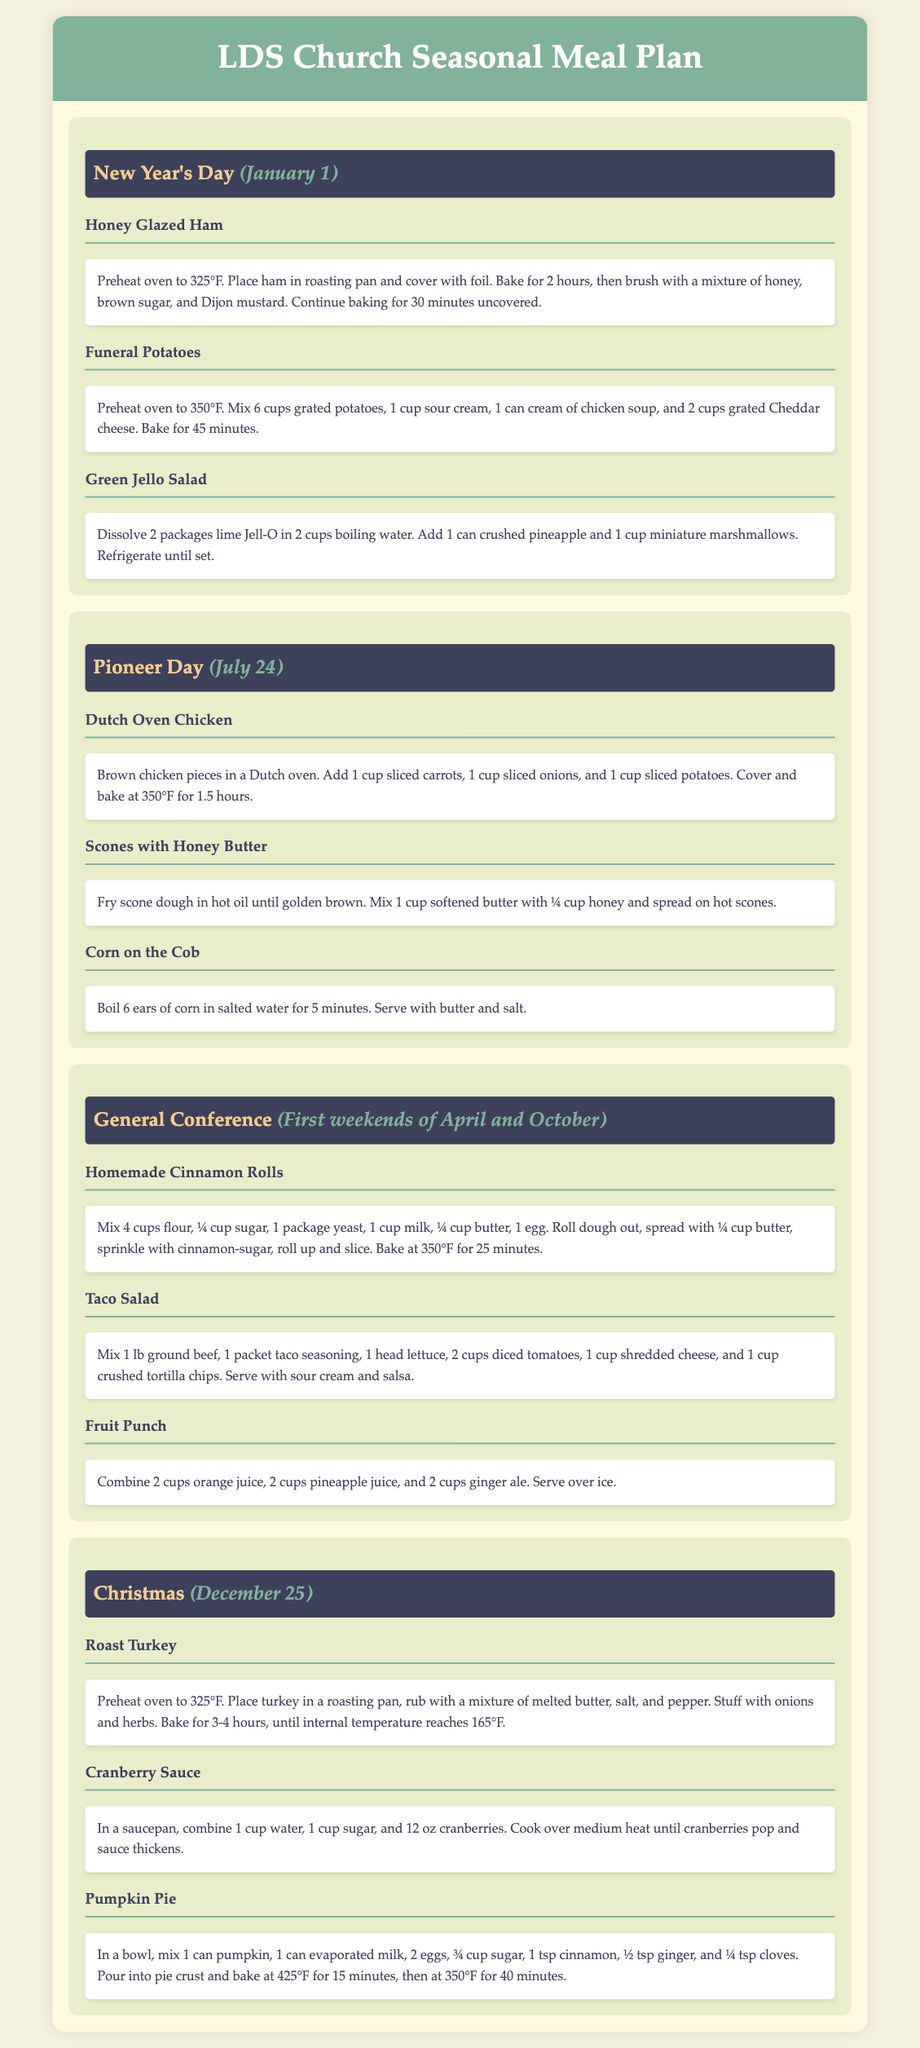What is the first dish listed for New Year's Day? The first dish is Honey Glazed Ham, as it is the first item in the New Year's meal plan section.
Answer: Honey Glazed Ham What date is Pioneer Day celebrated? The document states that Pioneer Day is on July 24, which is specified in the date section of the event.
Answer: July 24 How long do you bake the Honey Glazed Ham? The recipe states that the ham is baked for a total of 2 hours and then an additional 30 minutes uncovered.
Answer: 2 hours and 30 minutes What ingredient is used in the Funeral Potatoes recipe that provides creaminess? The recipe includes sour cream, which is mixed with the grated potatoes to provide creaminess.
Answer: Sour cream What is the main protein used in the General Conference dish Taco Salad? The main protein is ground beef, as mentioned in the recipe for Taco Salad.
Answer: Ground beef What type of dessert is served on Christmas? The document lists Pumpkin Pie as a dessert served for Christmas.
Answer: Pumpkin Pie How is Cranberry Sauce made according to the document? The recipe combines water, sugar, and cranberries, cooked until the sauce thickens, indicating it's a fruit-based sauce.
Answer: Cooked cranberries How many cups of orange juice are used in the Fruit Punch recipe? The Fruit Punch recipe uses 2 cups of orange juice, as stated in the ingredient list for the drink.
Answer: 2 cups What cooking method is mentioned for the Dutch Oven Chicken? The method used for the Dutch Oven Chicken involves baking after browning the chicken pieces.
Answer: Baking 